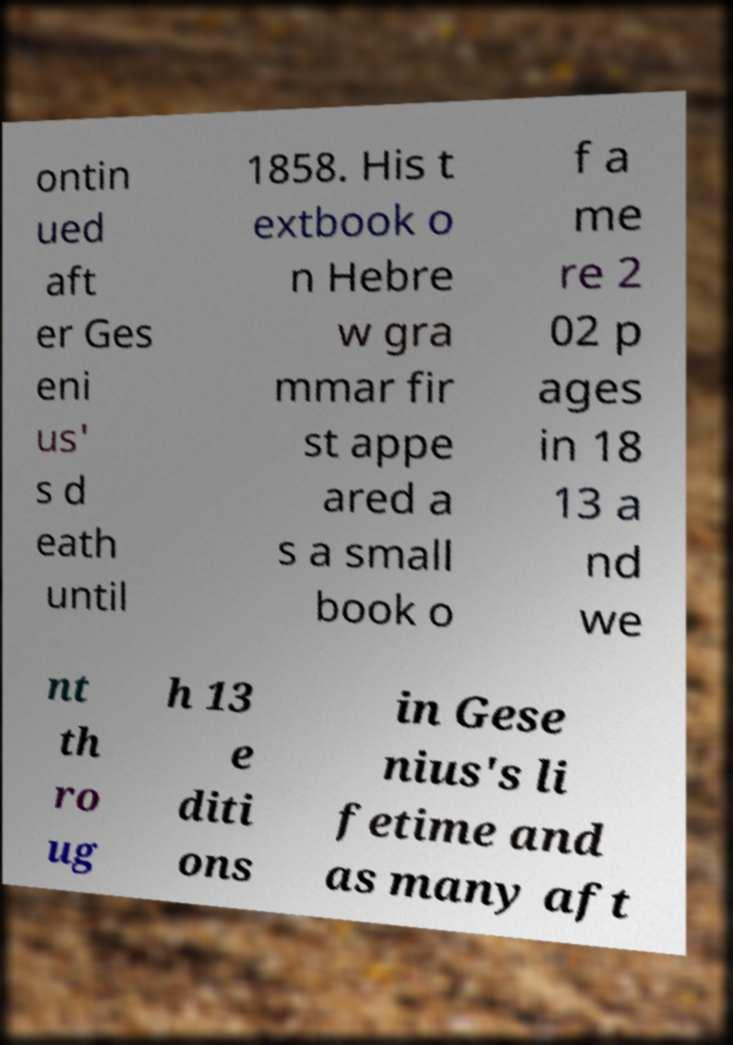What messages or text are displayed in this image? I need them in a readable, typed format. ontin ued aft er Ges eni us' s d eath until 1858. His t extbook o n Hebre w gra mmar fir st appe ared a s a small book o f a me re 2 02 p ages in 18 13 a nd we nt th ro ug h 13 e diti ons in Gese nius's li fetime and as many aft 